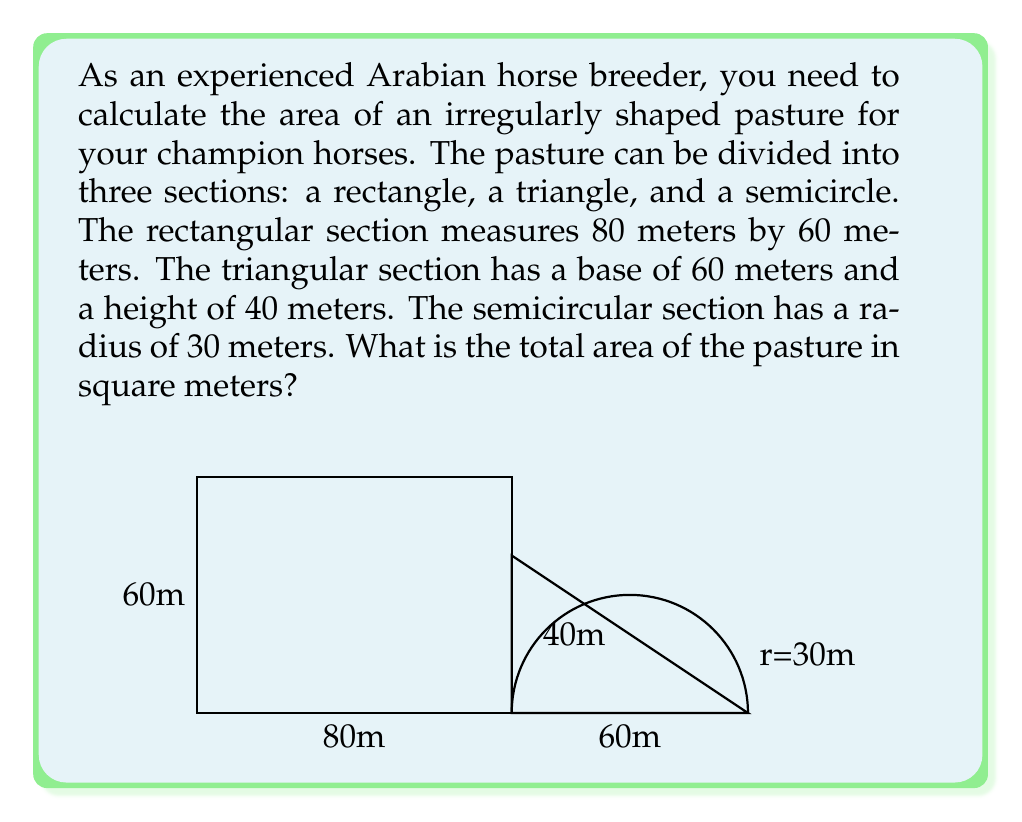Solve this math problem. To solve this problem, we need to calculate the area of each section and then sum them up:

1. Rectangle area:
   $A_r = l \times w = 80 \text{ m} \times 60 \text{ m} = 4800 \text{ m}^2$

2. Triangle area:
   $A_t = \frac{1}{2} \times b \times h = \frac{1}{2} \times 60 \text{ m} \times 40 \text{ m} = 1200 \text{ m}^2$

3. Semicircle area:
   $A_s = \frac{1}{2} \times \pi r^2 = \frac{1}{2} \times \pi \times (30 \text{ m})^2 = 1413.72 \text{ m}^2$

Now, we sum up all the areas:

$$A_{total} = A_r + A_t + A_s$$
$$A_{total} = 4800 \text{ m}^2 + 1200 \text{ m}^2 + 1413.72 \text{ m}^2$$
$$A_{total} = 7413.72 \text{ m}^2$$

Rounding to the nearest whole number, we get 7414 square meters.
Answer: The total area of the irregularly shaped pasture is approximately 7414 square meters. 